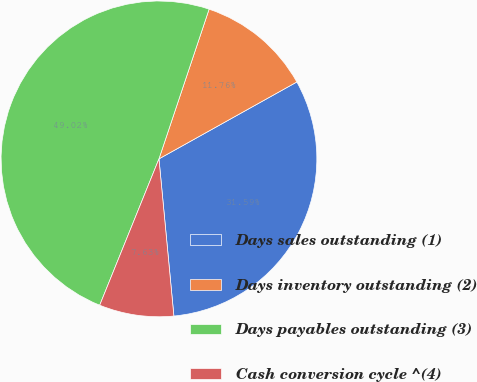Convert chart. <chart><loc_0><loc_0><loc_500><loc_500><pie_chart><fcel>Days sales outstanding (1)<fcel>Days inventory outstanding (2)<fcel>Days payables outstanding (3)<fcel>Cash conversion cycle ^(4)<nl><fcel>31.59%<fcel>11.76%<fcel>49.02%<fcel>7.63%<nl></chart> 